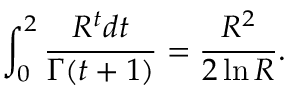<formula> <loc_0><loc_0><loc_500><loc_500>\int _ { 0 } ^ { 2 } \frac { R ^ { t } d t } { \Gamma ( t + 1 ) } = \frac { R ^ { 2 } } { 2 \ln R } .</formula> 